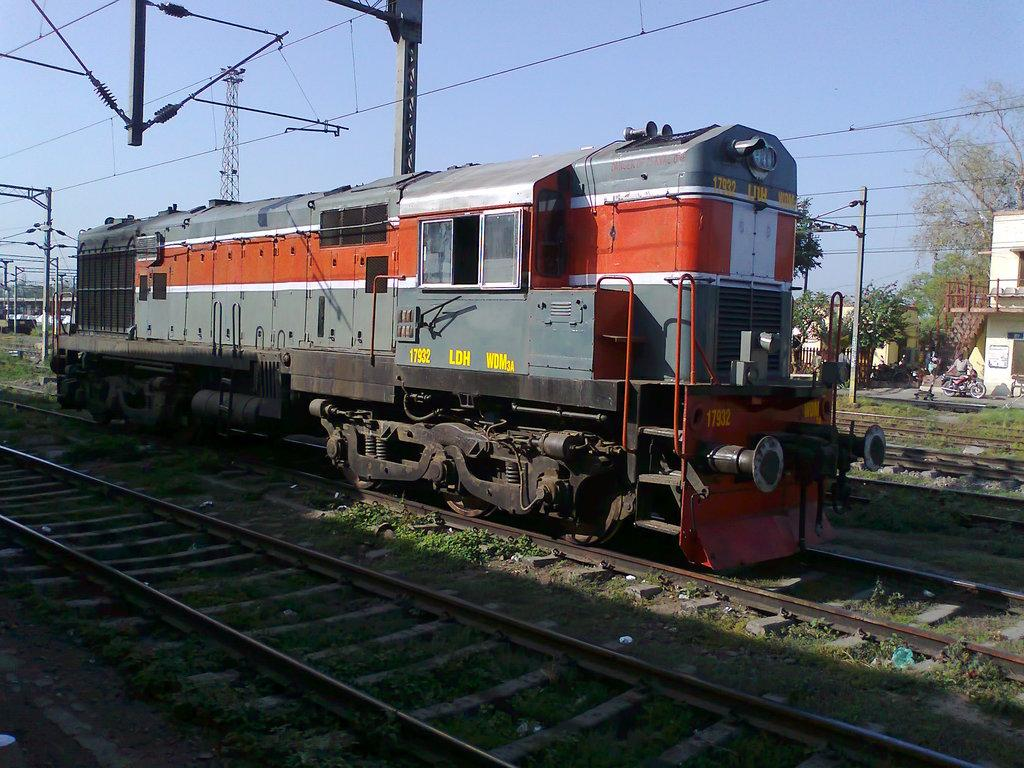What is the main subject of the image? There is a train in the image. Can you describe the color of the train? The train is gray and orange in color. Where is the train located in the image? The train is on a track. What can be seen in the background of the image? There are electric poles, trees in green color, and the sky in blue color in the background of the image. What type of beef is being served on the train in the image? There is no beef present in the image, as it features a train on a track with a background of electric poles, trees, and the sky. 